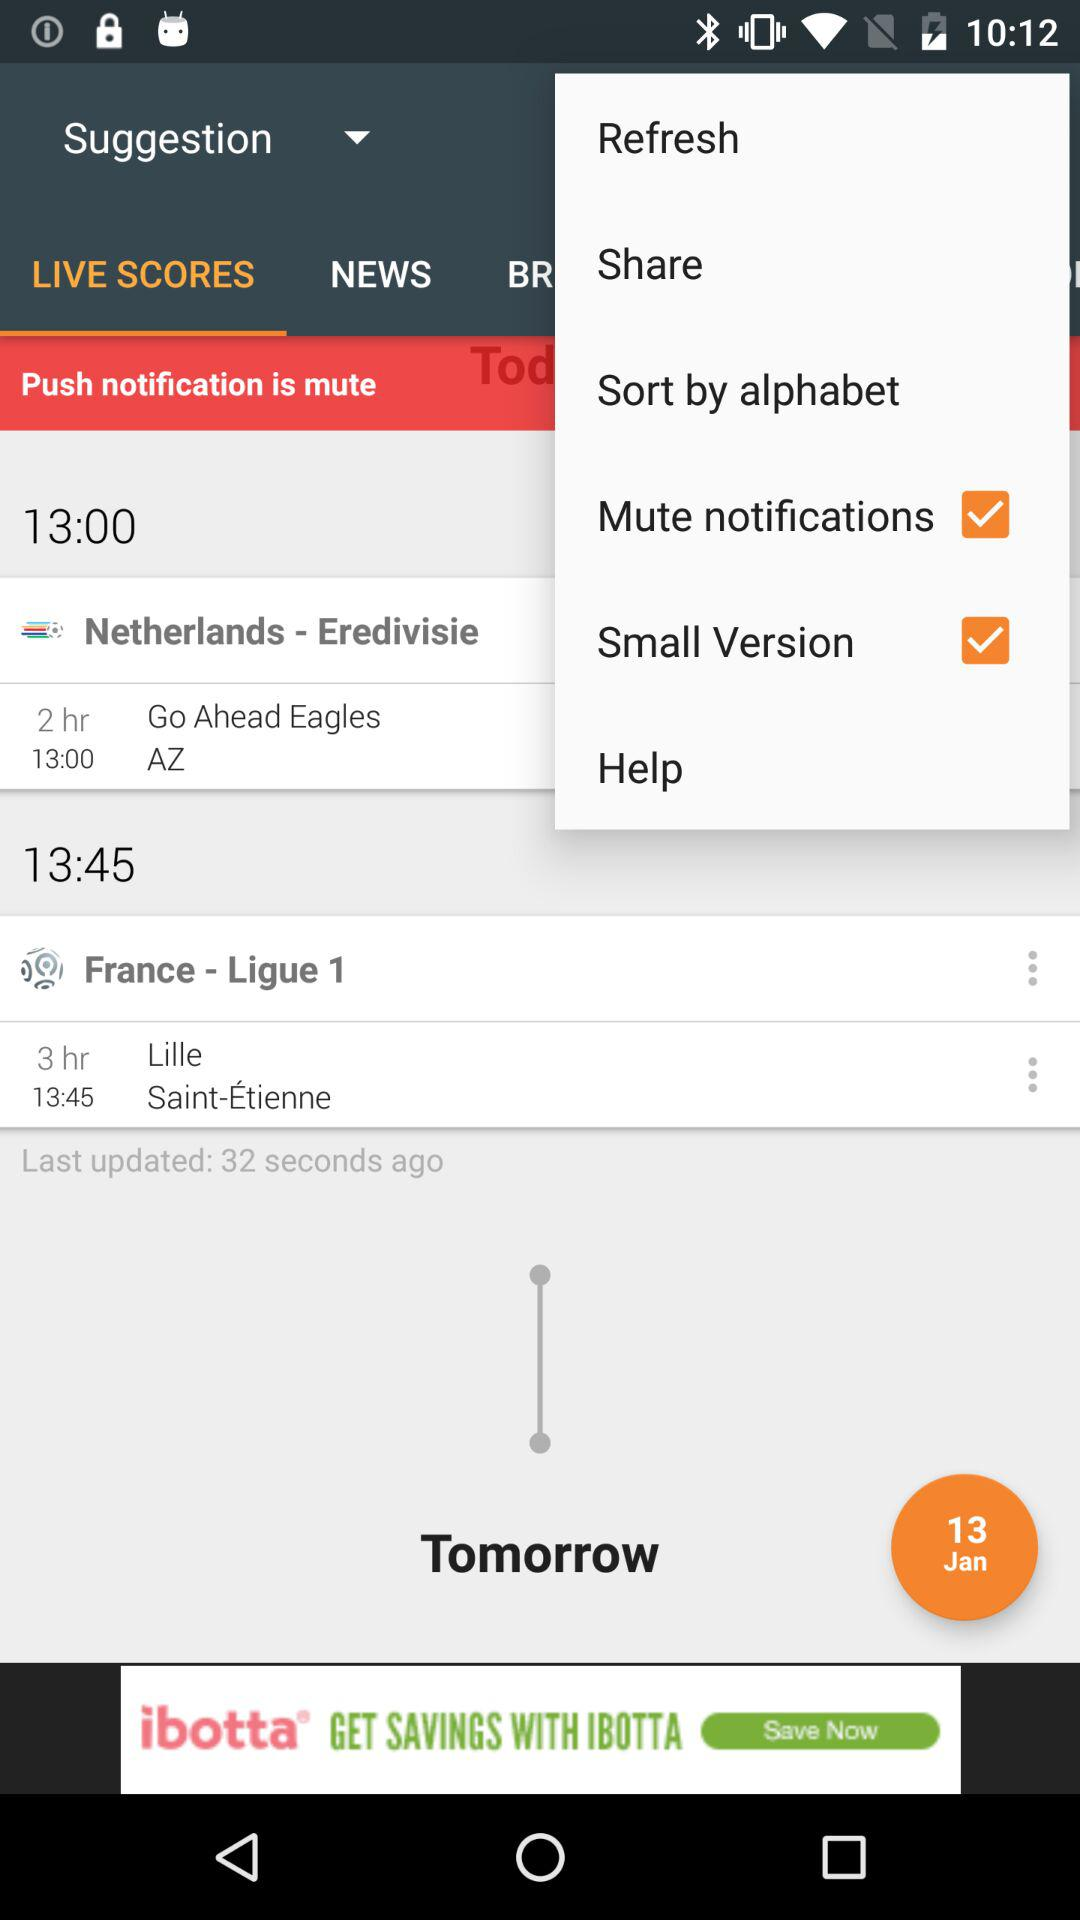What is the status of "Mute notifications"? The status is "on". 